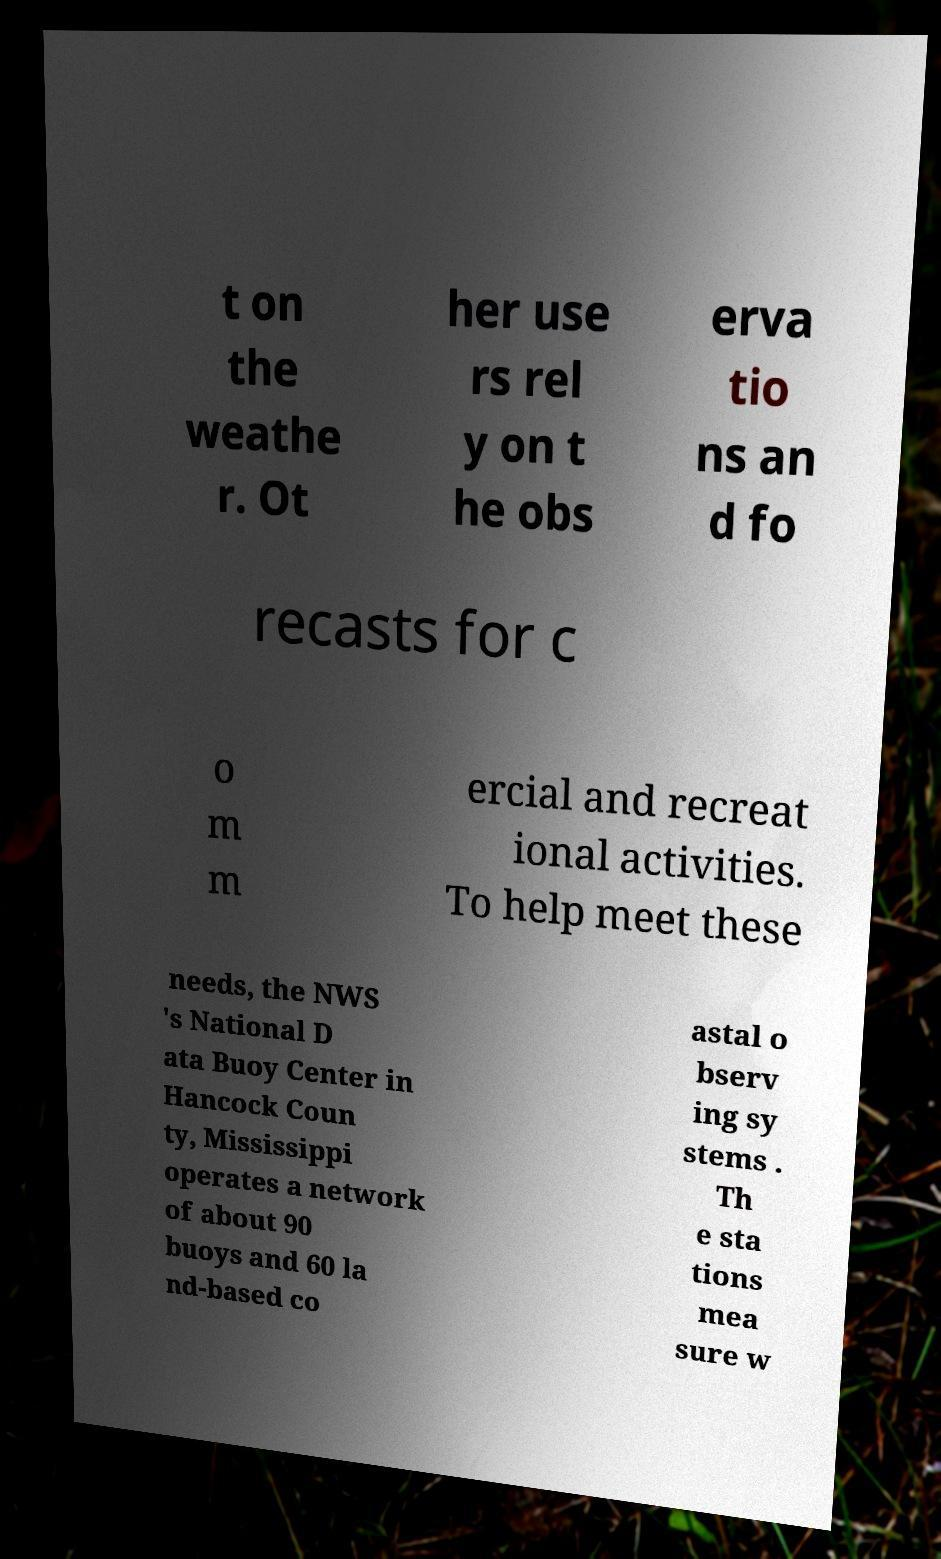What messages or text are displayed in this image? I need them in a readable, typed format. t on the weathe r. Ot her use rs rel y on t he obs erva tio ns an d fo recasts for c o m m ercial and recreat ional activities. To help meet these needs, the NWS 's National D ata Buoy Center in Hancock Coun ty, Mississippi operates a network of about 90 buoys and 60 la nd-based co astal o bserv ing sy stems . Th e sta tions mea sure w 